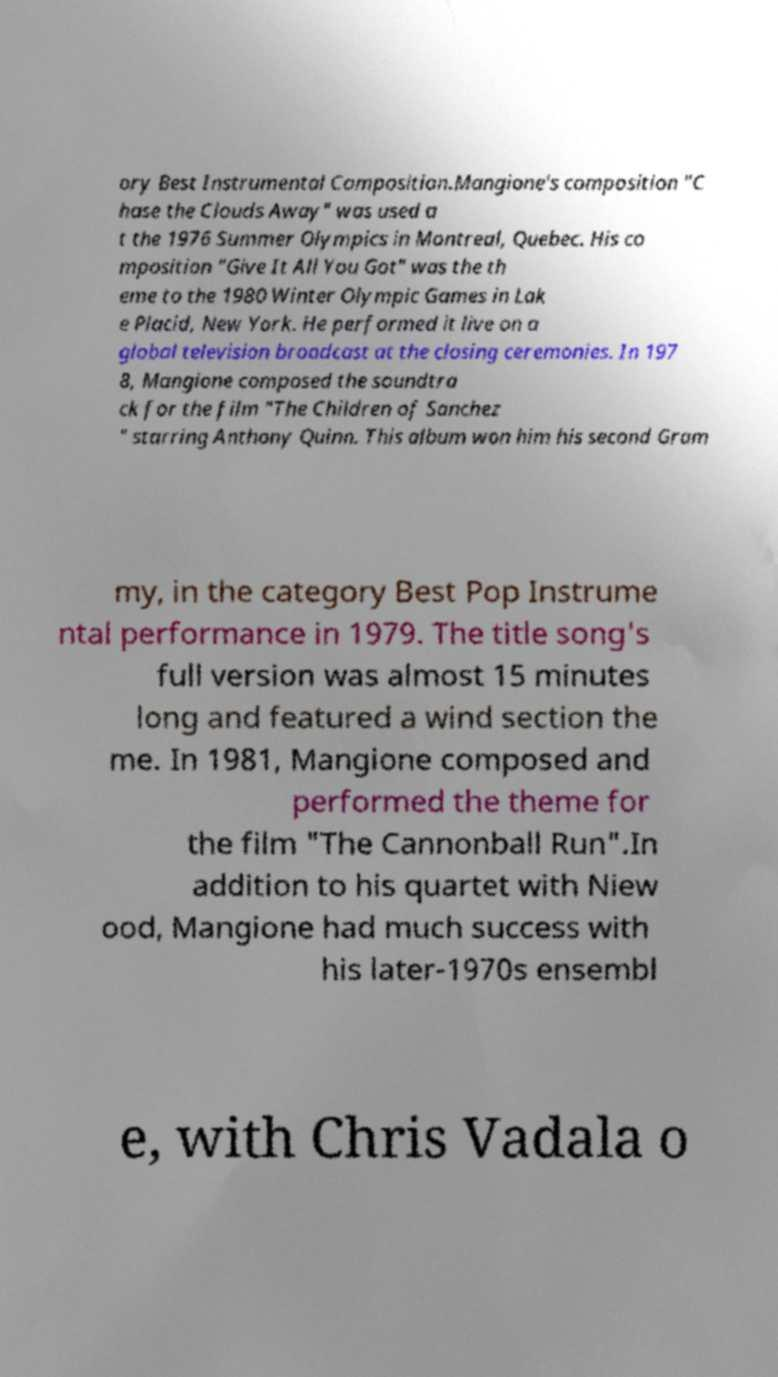What messages or text are displayed in this image? I need them in a readable, typed format. ory Best Instrumental Composition.Mangione's composition "C hase the Clouds Away" was used a t the 1976 Summer Olympics in Montreal, Quebec. His co mposition "Give It All You Got" was the th eme to the 1980 Winter Olympic Games in Lak e Placid, New York. He performed it live on a global television broadcast at the closing ceremonies. In 197 8, Mangione composed the soundtra ck for the film "The Children of Sanchez " starring Anthony Quinn. This album won him his second Gram my, in the category Best Pop Instrume ntal performance in 1979. The title song's full version was almost 15 minutes long and featured a wind section the me. In 1981, Mangione composed and performed the theme for the film "The Cannonball Run".In addition to his quartet with Niew ood, Mangione had much success with his later-1970s ensembl e, with Chris Vadala o 